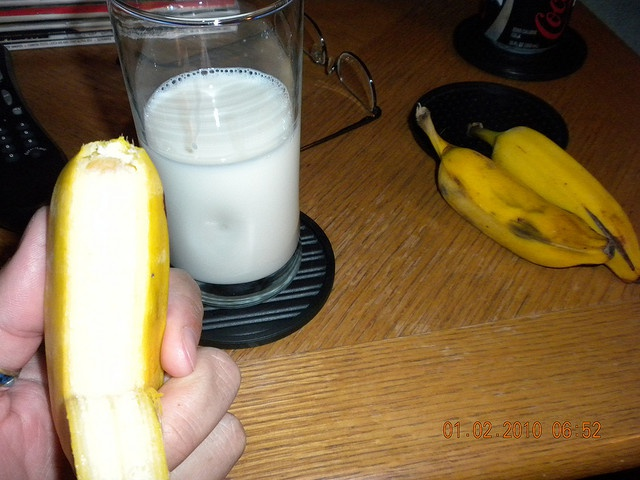Describe the objects in this image and their specific colors. I can see cup in gray, lightgray, darkgray, and black tones, banana in gray, ivory, khaki, and gold tones, people in gray, lightpink, darkgray, and pink tones, banana in gray, olive, and black tones, and banana in gray, olive, and black tones in this image. 